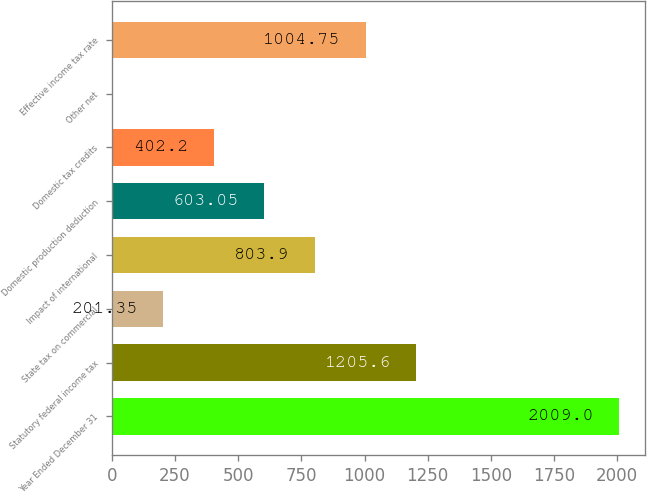<chart> <loc_0><loc_0><loc_500><loc_500><bar_chart><fcel>Year Ended December 31<fcel>Statutory federal income tax<fcel>State tax on commercial<fcel>Impact of international<fcel>Domestic production deduction<fcel>Domestic tax credits<fcel>Other net<fcel>Effective income tax rate<nl><fcel>2009<fcel>1205.6<fcel>201.35<fcel>803.9<fcel>603.05<fcel>402.2<fcel>0.5<fcel>1004.75<nl></chart> 